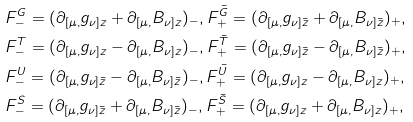Convert formula to latex. <formula><loc_0><loc_0><loc_500><loc_500>& F ^ { G } _ { - } = ( \partial _ { [ \mu , } g _ { \nu ] z } + \partial _ { [ \mu , } B _ { \nu ] z } ) _ { - } , F ^ { \bar { G } } _ { + } = ( \partial _ { [ \mu , } g _ { \nu ] \bar { z } } + \partial _ { [ \mu , } B _ { \nu ] \bar { z } } ) _ { + } , \\ & F ^ { T } _ { - } = ( \partial _ { [ \mu , } g _ { \nu ] z } - \partial _ { [ \mu , } B _ { \nu ] z } ) _ { - } , F ^ { \bar { T } } _ { + } = ( \partial _ { [ \mu , } g _ { \nu ] \bar { z } } - \partial _ { [ \mu , } B _ { \nu ] \bar { z } } ) _ { + } , \\ & F ^ { U } _ { - } = ( \partial _ { [ \mu , } g _ { \nu ] \bar { z } } - \partial _ { [ \mu , } B _ { \nu ] \bar { z } } ) _ { - } , F ^ { \bar { U } } _ { + } = ( \partial _ { [ \mu , } g _ { \nu ] z } - \partial _ { [ \mu , } B _ { \nu ] z } ) _ { + } , \\ & F ^ { S } _ { - } = ( \partial _ { [ \mu , } g _ { \nu ] \bar { z } } + \partial _ { [ \mu , } B _ { \nu ] \bar { z } } ) _ { - } , F ^ { \bar { S } } _ { + } = ( \partial _ { [ \mu , } g _ { \nu ] z } + \partial _ { [ \mu , } B _ { \nu ] z } ) _ { + } , \\</formula> 